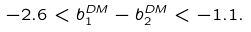<formula> <loc_0><loc_0><loc_500><loc_500>- 2 . 6 < b _ { 1 } ^ { D M } - b _ { 2 } ^ { D M } < - 1 . 1 .</formula> 